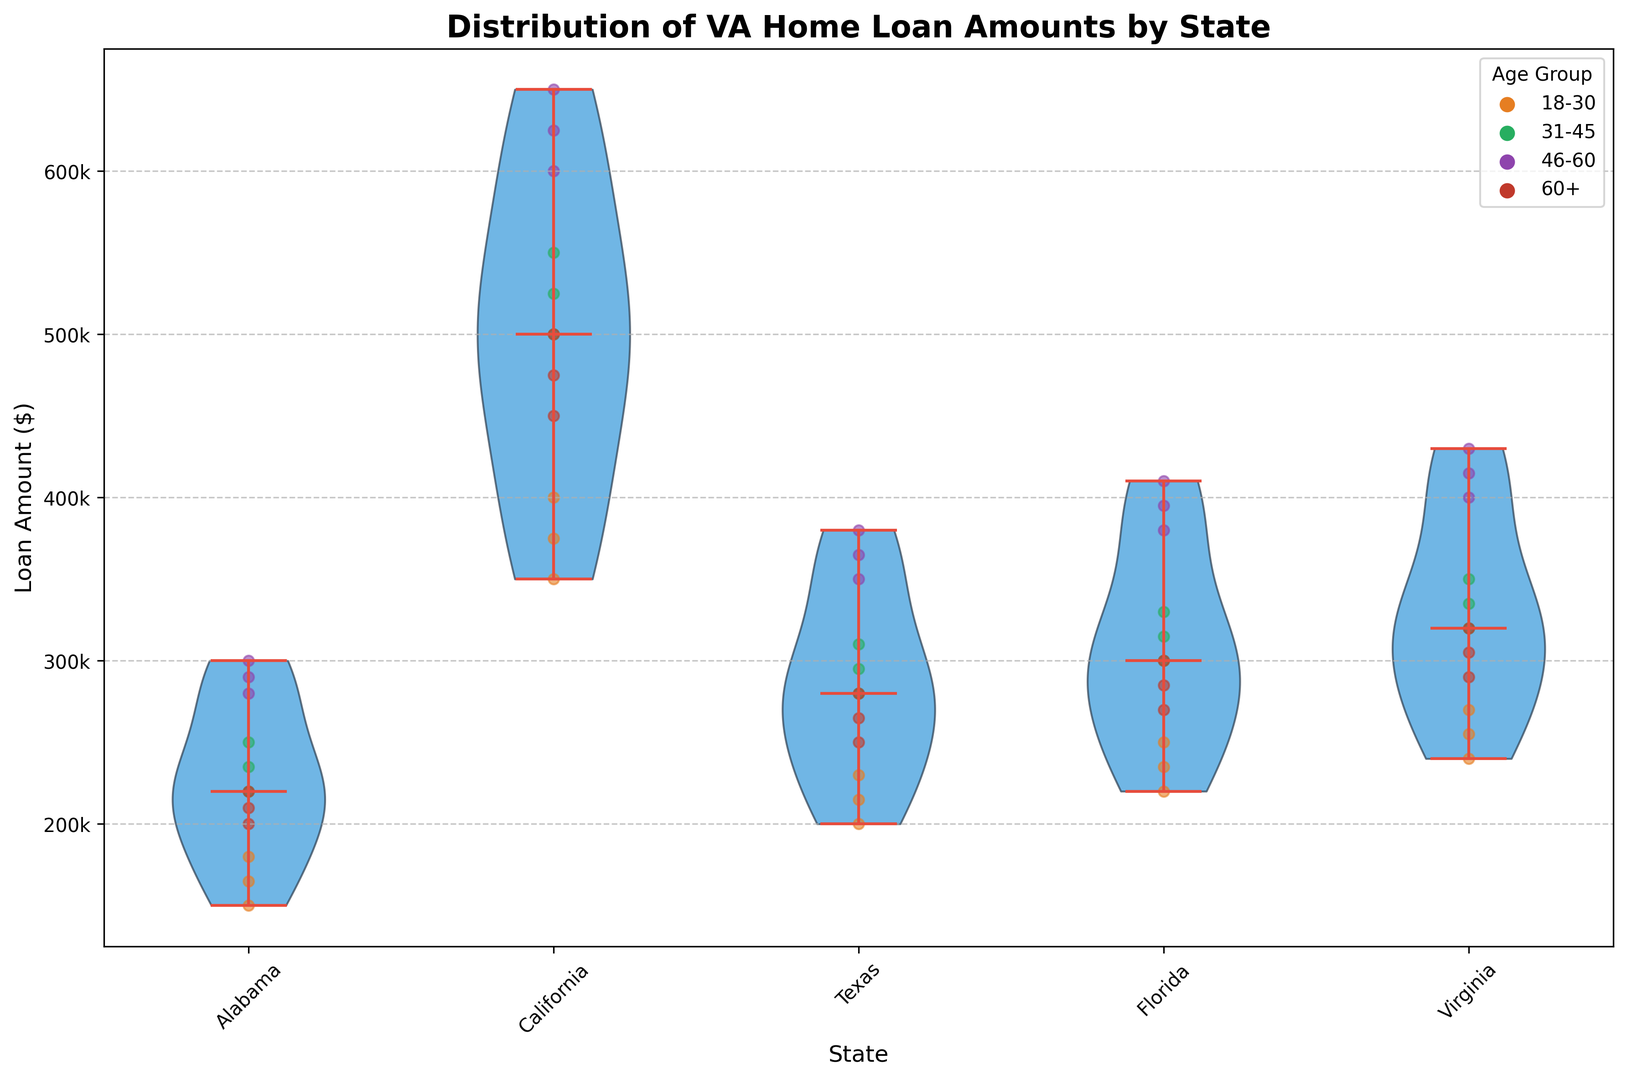Which state has the highest median loan amount? The figure shows the median values with a horizontal line within each violin plot. The state with the highest median line is the one we are looking for.
Answer: California Compare the median loan amounts between Alabama and Virginia. Which is higher? By comparing the horizontal median lines within the violin plots for Alabama and Virginia, we can see which state's median loan amount is higher.
Answer: Virginia What range of loan amounts do veterans aged 46-60 in Texas typically receive? In the plot, the spread of the violin plot for each age group represents the range of loan amounts. For veterans aged 46-60 in Texas, look at the spread of the green dots within the Texas violin plot.
Answer: Approximately $350,000 to $380,000 Which age group in California has the lowest median loan amount? Each age group is represented by different colored dots. The median is shown by the white dot within each color group. Identify which age group in California has the lowest white dot.
Answer: Veterans aged 60+ Do veterans aged 31-45 in Florida generally receive higher loan amounts than those in Alabama? Compare the orange dots in the Florida and Alabama violin plots. Assess whether the Florida dots generally appear at higher value positions than the Alabama dots.
Answer: Yes What is the approximate difference in median loan amounts between veterans aged 18-30 in California and those aged 46-60 in Florida? Identify the median of the corresponding age groups shown by white dots within the specific colored dots. Subtract the Florida 46-60 median from the California 18-30 median.
Answer: Approximately $275,000 How does the variability in loan amounts for veterans aged 60+ in Alabama compare to that group in Virginia? Variability can be inferred by the width and spread of the violin plots. Compare the spread and width of dots for the age group 60+ in Alabama and Virginia.
Answer: Virginia has higher variability What is the average range (from minimum to maximum) of loan amounts in Texas? To find the range for Texas, locate the lowest and highest points of the violin plot. Subtract the minimum value from the maximum value within the Texas violin plot.
Answer: Approximately $180,000 Which state shows the smallest variation in loan amounts for age group 18-30? Look at the width and spread of the violin plots for the age group 18-30 in each state. The state with the narrowest plot has the smallest variation.
Answer: Alabama Is there any state where veterans aged 46-60 have median loan amounts similar to those aged 18-30? Compare the median values (white dots) of 46-60 group with 18-30 group across all states. Identify if any state has overlapping or closely positioned medians.
Answer: No 